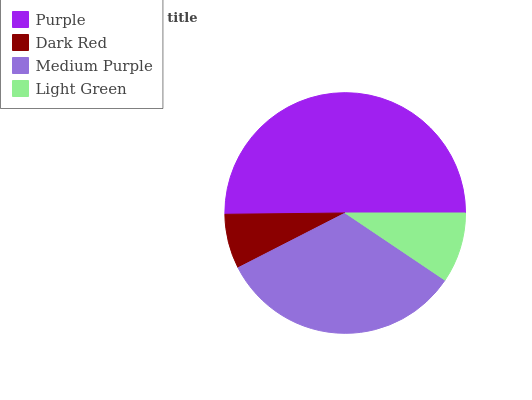Is Dark Red the minimum?
Answer yes or no. Yes. Is Purple the maximum?
Answer yes or no. Yes. Is Medium Purple the minimum?
Answer yes or no. No. Is Medium Purple the maximum?
Answer yes or no. No. Is Medium Purple greater than Dark Red?
Answer yes or no. Yes. Is Dark Red less than Medium Purple?
Answer yes or no. Yes. Is Dark Red greater than Medium Purple?
Answer yes or no. No. Is Medium Purple less than Dark Red?
Answer yes or no. No. Is Medium Purple the high median?
Answer yes or no. Yes. Is Light Green the low median?
Answer yes or no. Yes. Is Purple the high median?
Answer yes or no. No. Is Medium Purple the low median?
Answer yes or no. No. 